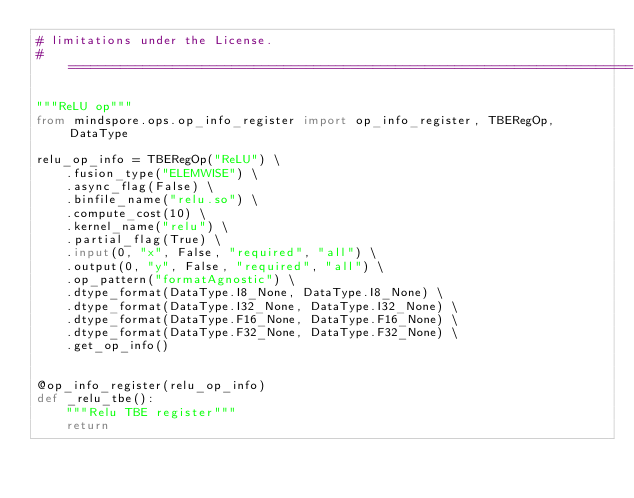Convert code to text. <code><loc_0><loc_0><loc_500><loc_500><_Python_># limitations under the License.
# ============================================================================

"""ReLU op"""
from mindspore.ops.op_info_register import op_info_register, TBERegOp, DataType

relu_op_info = TBERegOp("ReLU") \
    .fusion_type("ELEMWISE") \
    .async_flag(False) \
    .binfile_name("relu.so") \
    .compute_cost(10) \
    .kernel_name("relu") \
    .partial_flag(True) \
    .input(0, "x", False, "required", "all") \
    .output(0, "y", False, "required", "all") \
    .op_pattern("formatAgnostic") \
    .dtype_format(DataType.I8_None, DataType.I8_None) \
    .dtype_format(DataType.I32_None, DataType.I32_None) \
    .dtype_format(DataType.F16_None, DataType.F16_None) \
    .dtype_format(DataType.F32_None, DataType.F32_None) \
    .get_op_info()


@op_info_register(relu_op_info)
def _relu_tbe():
    """Relu TBE register"""
    return
</code> 